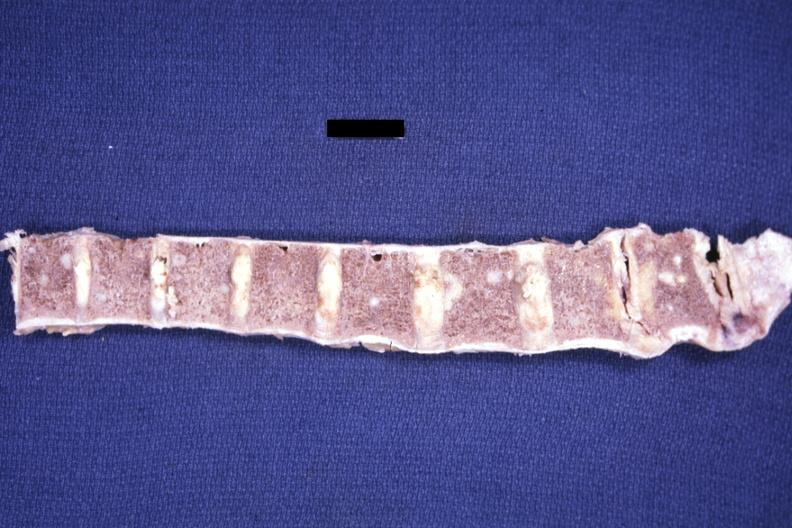s joints present?
Answer the question using a single word or phrase. Yes 